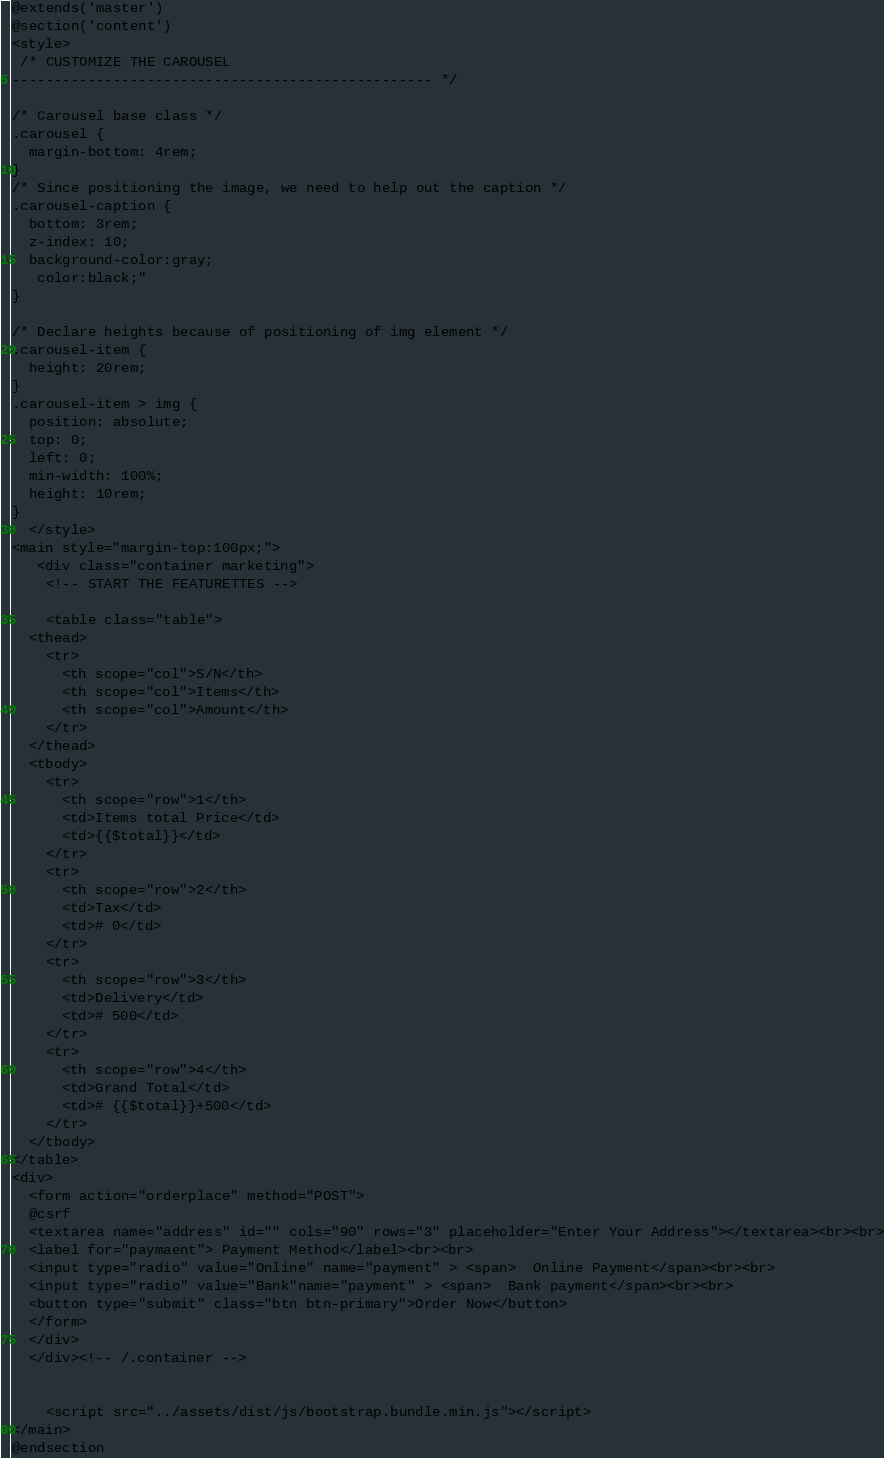Convert code to text. <code><loc_0><loc_0><loc_500><loc_500><_PHP_>@extends('master')
@section('content')
<style>
 /* CUSTOMIZE THE CAROUSEL
-------------------------------------------------- */

/* Carousel base class */
.carousel {
  margin-bottom: 4rem;
}
/* Since positioning the image, we need to help out the caption */
.carousel-caption {
  bottom: 3rem;
  z-index: 10;
  background-color:gray;
   color:black;"
}

/* Declare heights because of positioning of img element */
.carousel-item {
  height: 20rem;
}
.carousel-item > img {
  position: absolute;
  top: 0;
  left: 0;
  min-width: 100%;
  height: 10rem;
}
  </style>
<main style="margin-top:100px;">
   <div class="container marketing">
    <!-- START THE FEATURETTES -->

    <table class="table">
  <thead>
    <tr>
      <th scope="col">S/N</th>
      <th scope="col">Items</th>
      <th scope="col">Amount</th>
    </tr>
  </thead>
  <tbody>
    <tr>
      <th scope="row">1</th>
      <td>Items total Price</td>
      <td>{{$total}}</td>
    </tr>
    <tr>
      <th scope="row">2</th>
      <td>Tax</td>
      <td># 0</td> 
    </tr>
    <tr>
      <th scope="row">3</th>
      <td>Delivery</td>
      <td># 500</td> 
    </tr>
    <tr>
      <th scope="row">4</th>
      <td>Grand Total</td>
      <td># {{$total}}+500</td> 
    </tr>
  </tbody>
</table>
<div>
  <form action="orderplace" method="POST">
  @csrf
  <textarea name="address" id="" cols="90" rows="3" placeholder="Enter Your Address"></textarea><br><br>
  <label for="paymaent"> Payment Method</label><br><br>
  <input type="radio" value="Online" name="payment" > <span>  Online Payment</span><br><br>
  <input type="radio" value="Bank"name="payment" > <span>  Bank payment</span><br><br>
  <button type="submit" class="btn btn-primary">Order Now</button>
  </form>
  </div>
  </div><!-- /.container -->
  

    <script src="../assets/dist/js/bootstrap.bundle.min.js"></script>
</main>
@endsection</code> 